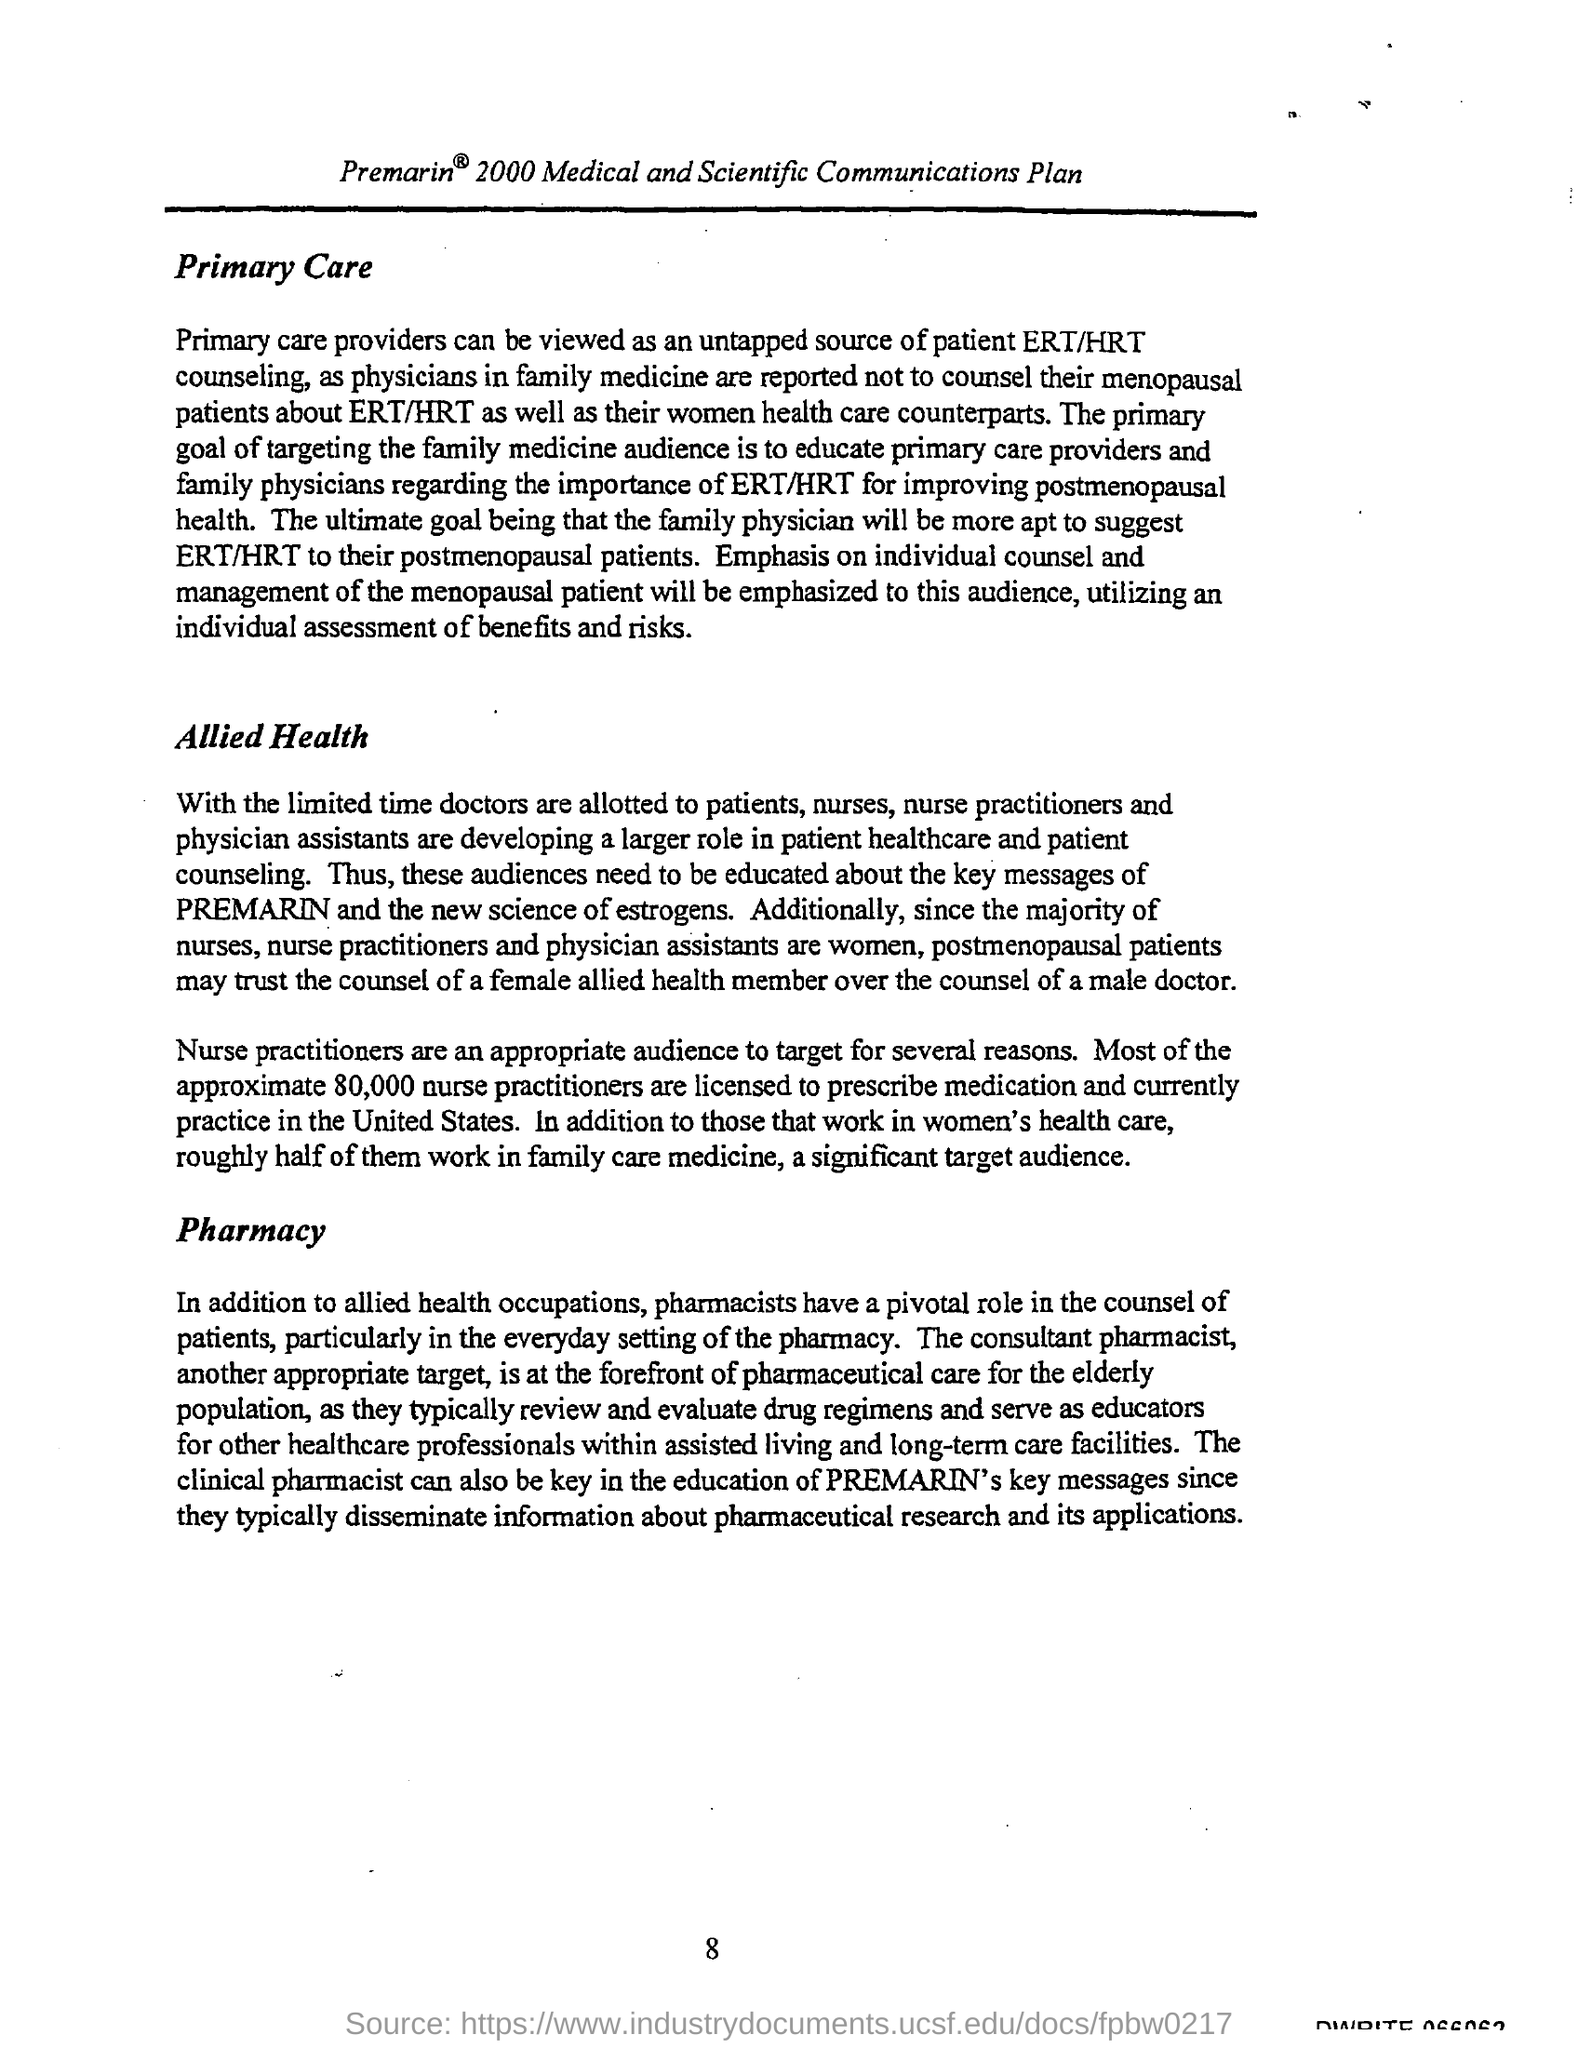Point out several critical features in this image. There are approximately 80,000 nurse practitioners licensed to prescribe medication in the United States. It is appropriate to target nurse practitioners as an audience for several reasons. 